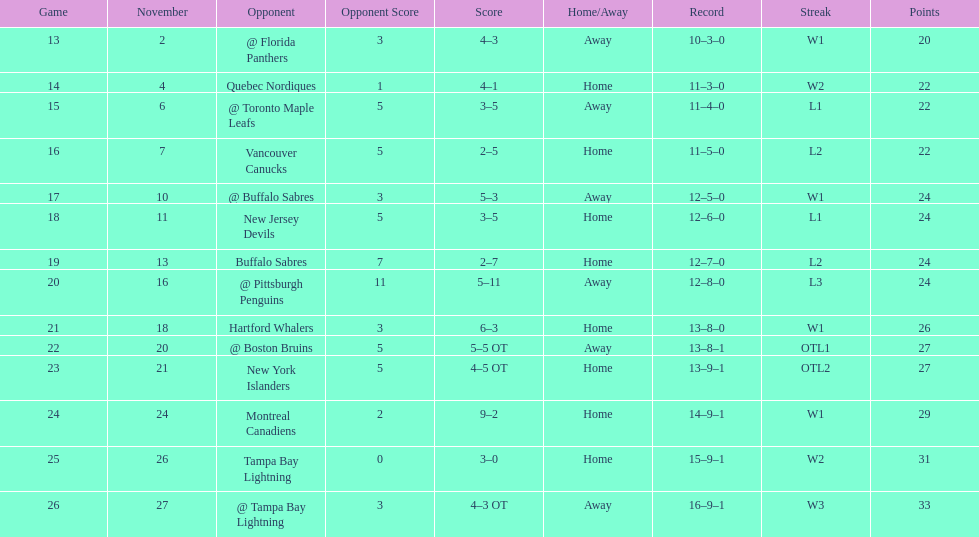Which was the only team in the atlantic division in the 1993-1994 season to acquire less points than the philadelphia flyers? Tampa Bay Lightning. 